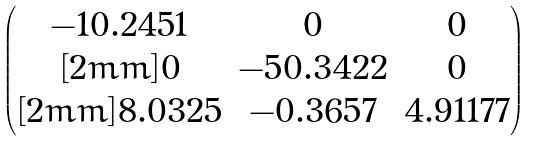Convert formula to latex. <formula><loc_0><loc_0><loc_500><loc_500>\begin{pmatrix} - 1 0 . 2 4 5 1 & 0 & 0 \\ [ 2 m m ] 0 & - 5 0 . 3 4 2 2 & 0 \\ [ 2 m m ] 8 . 0 3 2 5 & - 0 . 3 6 5 7 & 4 . 9 1 1 7 7 \end{pmatrix}</formula> 